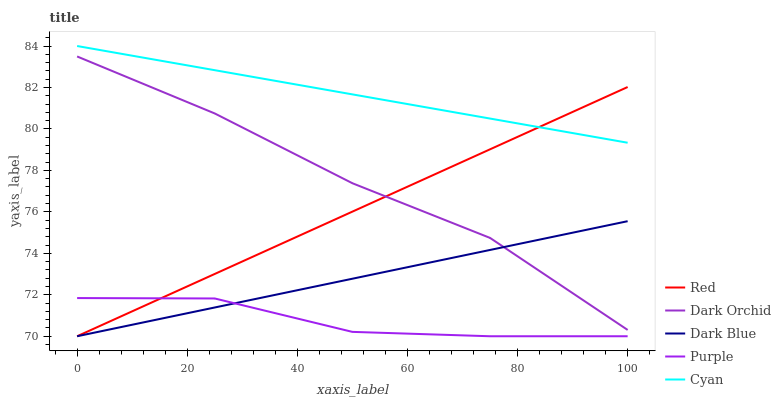Does Purple have the minimum area under the curve?
Answer yes or no. Yes. Does Cyan have the maximum area under the curve?
Answer yes or no. Yes. Does Dark Blue have the minimum area under the curve?
Answer yes or no. No. Does Dark Blue have the maximum area under the curve?
Answer yes or no. No. Is Cyan the smoothest?
Answer yes or no. Yes. Is Purple the roughest?
Answer yes or no. Yes. Is Dark Blue the smoothest?
Answer yes or no. No. Is Dark Blue the roughest?
Answer yes or no. No. Does Dark Orchid have the lowest value?
Answer yes or no. No. Does Cyan have the highest value?
Answer yes or no. Yes. Does Dark Blue have the highest value?
Answer yes or no. No. Is Purple less than Dark Orchid?
Answer yes or no. Yes. Is Cyan greater than Purple?
Answer yes or no. Yes. Does Purple intersect Dark Blue?
Answer yes or no. Yes. Is Purple less than Dark Blue?
Answer yes or no. No. Is Purple greater than Dark Blue?
Answer yes or no. No. Does Purple intersect Dark Orchid?
Answer yes or no. No. 